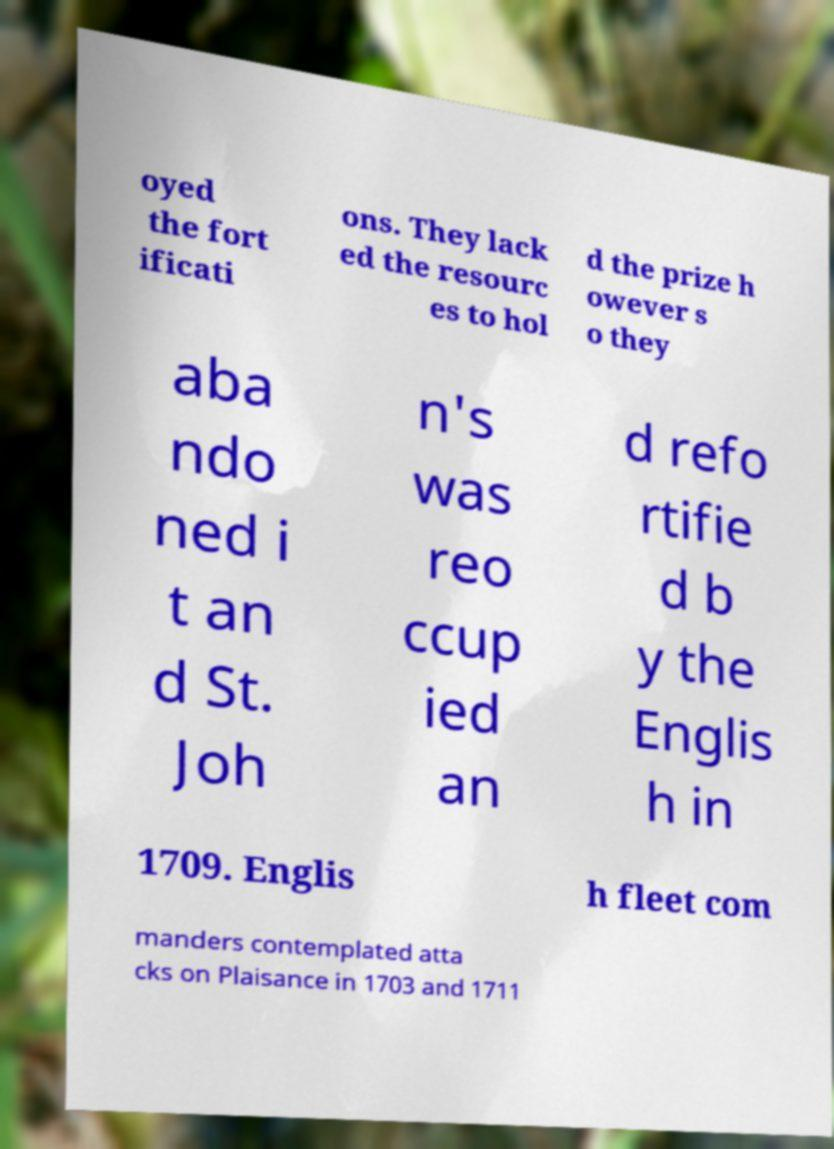There's text embedded in this image that I need extracted. Can you transcribe it verbatim? oyed the fort ificati ons. They lack ed the resourc es to hol d the prize h owever s o they aba ndo ned i t an d St. Joh n's was reo ccup ied an d refo rtifie d b y the Englis h in 1709. Englis h fleet com manders contemplated atta cks on Plaisance in 1703 and 1711 